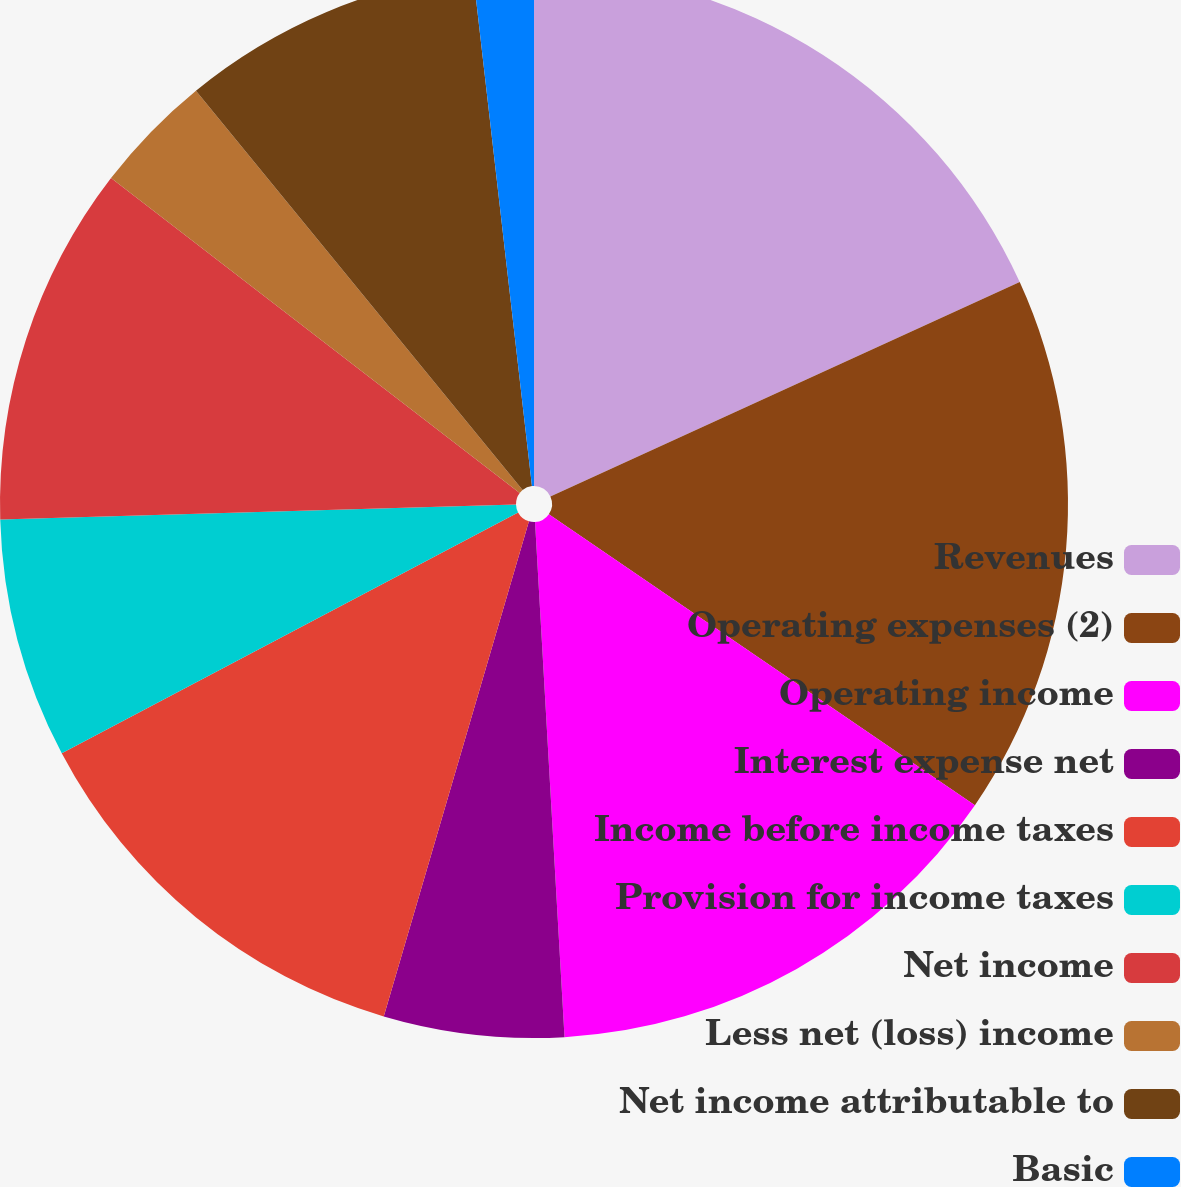Convert chart. <chart><loc_0><loc_0><loc_500><loc_500><pie_chart><fcel>Revenues<fcel>Operating expenses (2)<fcel>Operating income<fcel>Interest expense net<fcel>Income before income taxes<fcel>Provision for income taxes<fcel>Net income<fcel>Less net (loss) income<fcel>Net income attributable to<fcel>Basic<nl><fcel>18.18%<fcel>16.36%<fcel>14.55%<fcel>5.45%<fcel>12.73%<fcel>7.27%<fcel>10.91%<fcel>3.64%<fcel>9.09%<fcel>1.82%<nl></chart> 